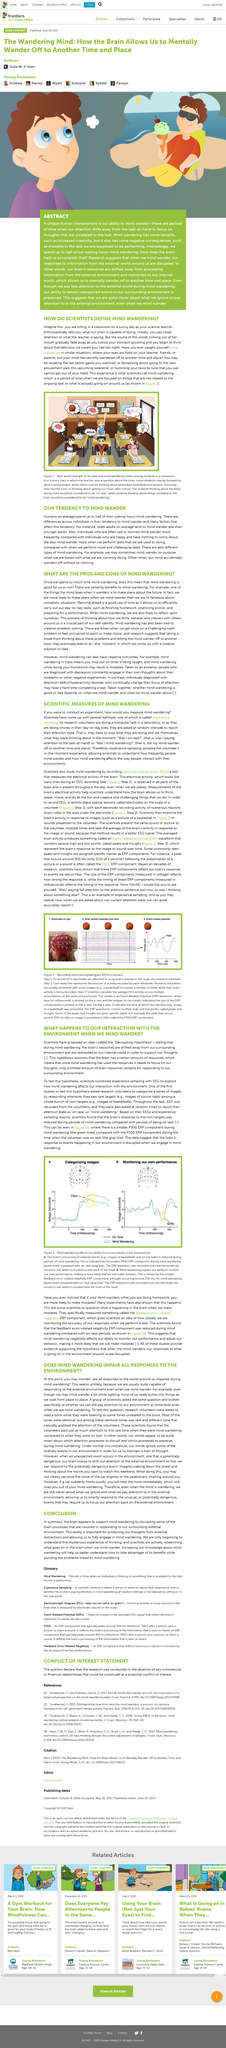Highlight a few significant elements in this photo. According to the "Decoupling Hypothesis," during mind wandering, the brain's resources are redirected away from the surrounding environment and towards internal thoughts and processes. There is a scientific method called "experience sampling" that is used to measure mind wandering. This method has been developed by scientists in order to study the phenomenon of mind wandering. Mind wandering is defined as a period of time during which an individual is fixated on thoughts or activities that are unrelated to the current task or surrounding environment. Researchers are investigating a phenomenon that involves the wandering of the mind. The Decoupling Hypothesis assumes that the brain has a limited amount of resources, which means that it can only respond to a limited number of events in the environment. 